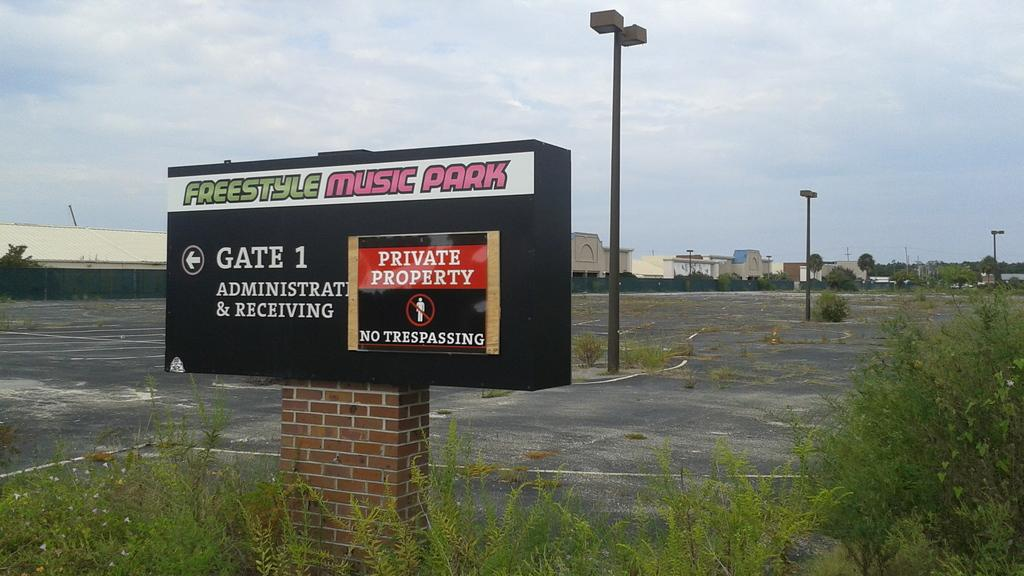<image>
Provide a brief description of the given image. A black sign for Gate 1 at the Freestyle Music Park. 